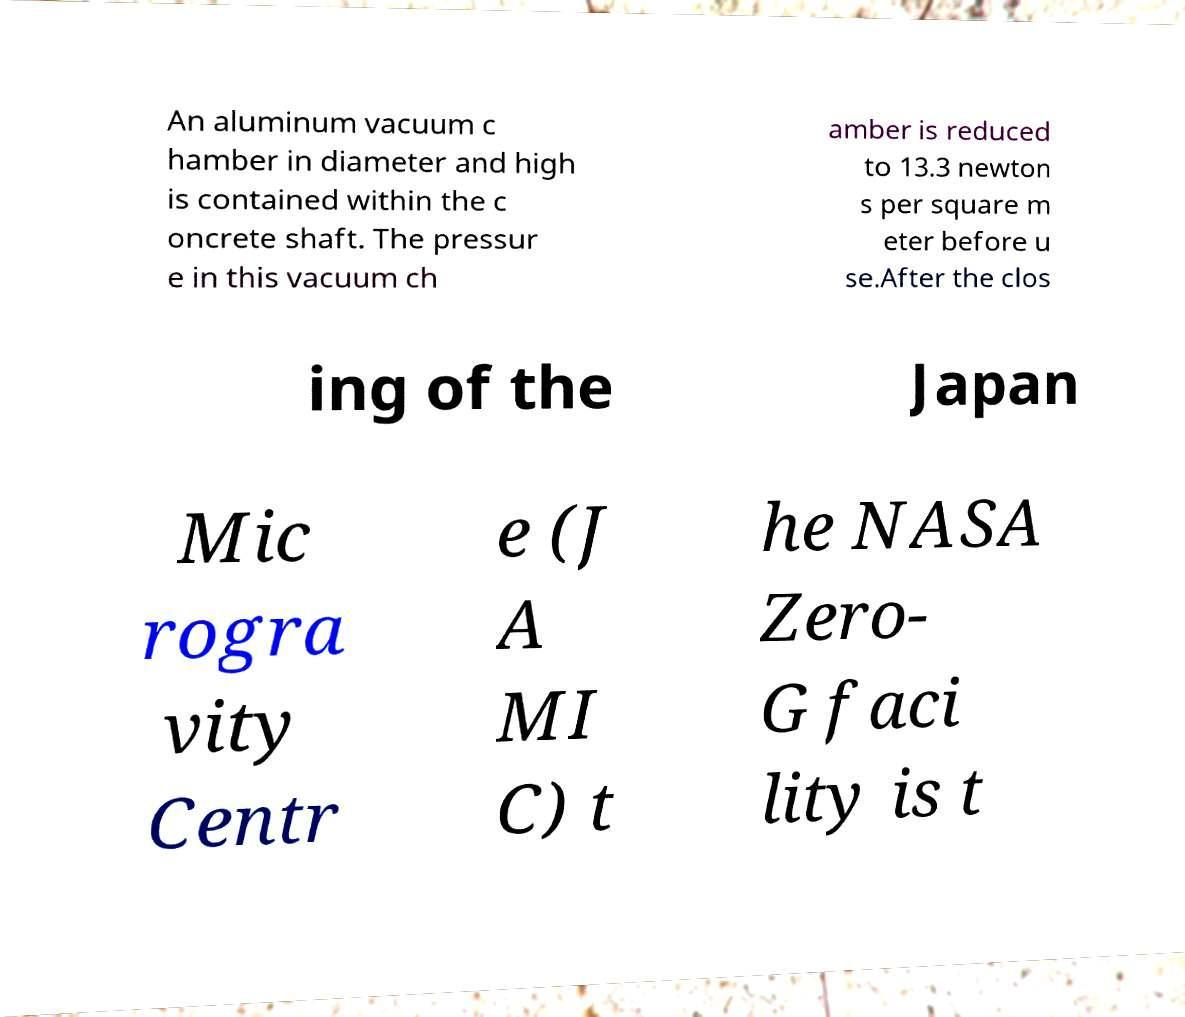Please identify and transcribe the text found in this image. An aluminum vacuum c hamber in diameter and high is contained within the c oncrete shaft. The pressur e in this vacuum ch amber is reduced to 13.3 newton s per square m eter before u se.After the clos ing of the Japan Mic rogra vity Centr e (J A MI C) t he NASA Zero- G faci lity is t 